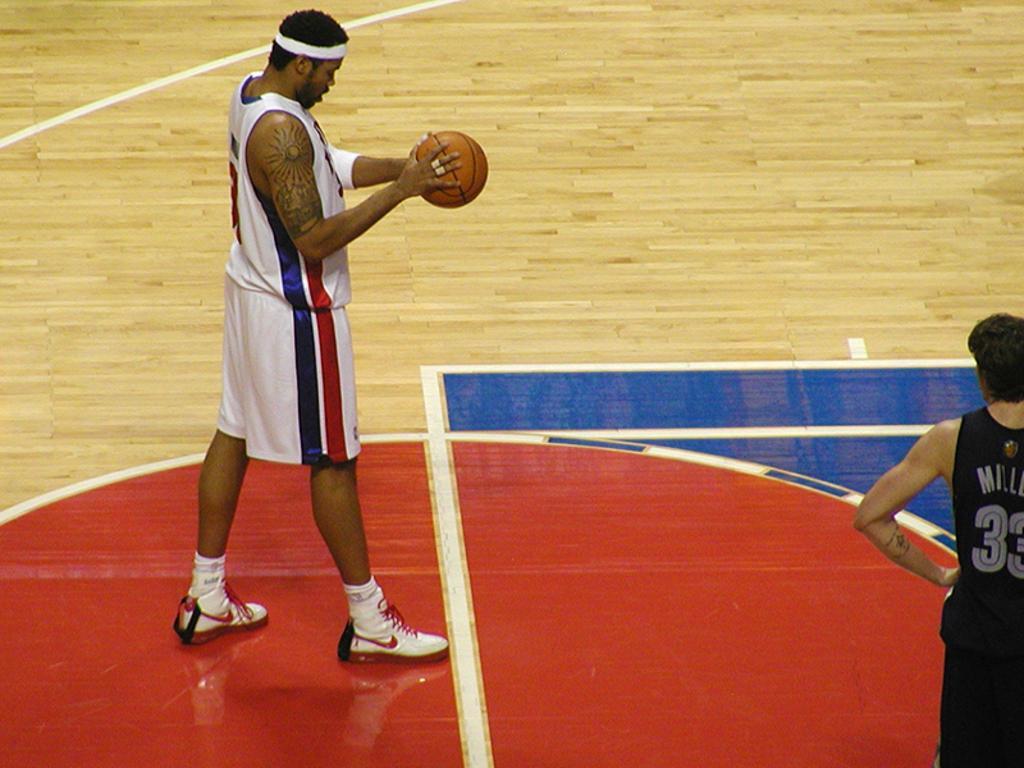How would you summarize this image in a sentence or two? In this picture there is a person wearing white dress is standing and holding a volleyball in his hand and there is another person standing in the right corner. 